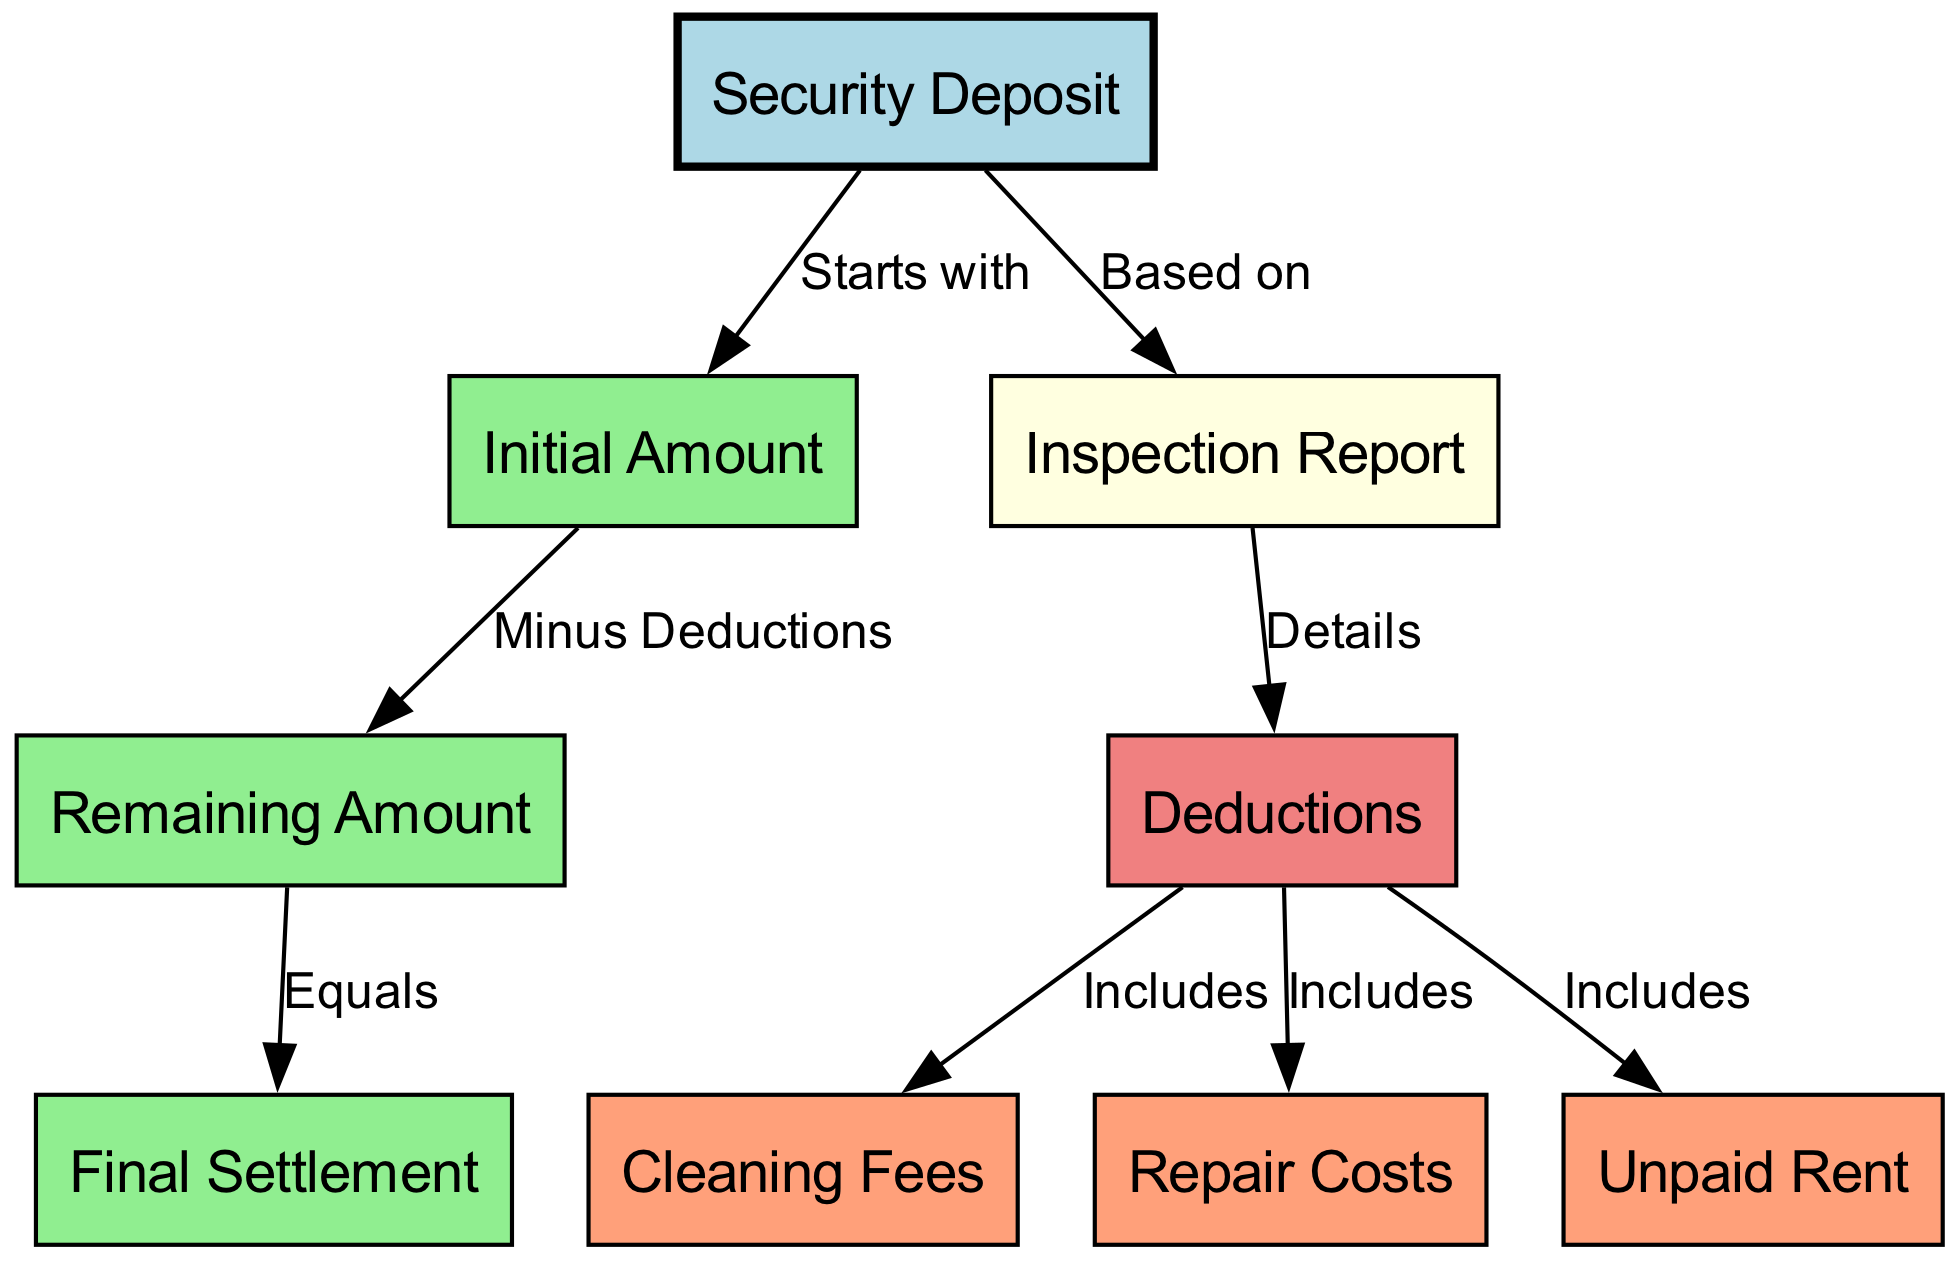What is the starting point in the security deposit process? The diagram indicates that the "Security Deposit" starts the process, as noted by the edge labeled "Starts with" pointing from "Security Deposit" to "Initial Amount."
Answer: Security Deposit How many types of deductions are included in the deductions? The diagram shows three deductions: "Cleaning Fees," "Repair Costs," and "Unpaid Rent," each connected to "Deductions" with an edge labeled "Includes." Counting these gives a total of three types.
Answer: Three What is the relationship between the remaining amount and the final settlement? The edge labeled "Equals" indicates that "Remaining Amount" directly leads to "Final Settlement," meaning the remaining amount determines the final settlement value.
Answer: Equals What reduces the initial amount in the security deposit process? According to the edge labeled "Minus Deductions," the deductions from the inspection report reduce the initial amount.
Answer: Deductions What document is the deductions based on? The "Inspection Report" provides the basis for the deductions, as indicated by the edge labeled "Based on."
Answer: Inspection Report How many nodes represent amounts in this diagram? The nodes "Initial Amount," "Remaining Amount," and "Final Settlement" each represent a monetary value, leading to a total of three nodes representing amounts.
Answer: Three What color represents the node labeled "Final Settlement"? The node labeled "Final Settlement" has been styled with a light green fill color, which visually distinguishes it from other nodes.
Answer: Light Green What includes cleaning fees and unpaid rent in the diagram? "Deductions" is the node that includes both "Cleaning Fees" and "Unpaid Rent," as denoted by edges labeled "Includes."
Answer: Deductions 